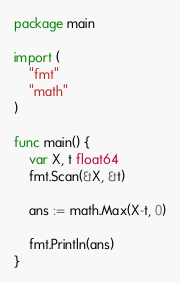Convert code to text. <code><loc_0><loc_0><loc_500><loc_500><_Go_>package main

import (
	"fmt"
	"math"
)

func main() {
	var X, t float64
	fmt.Scan(&X, &t)

	ans := math.Max(X-t, 0)

	fmt.Println(ans)
}
</code> 